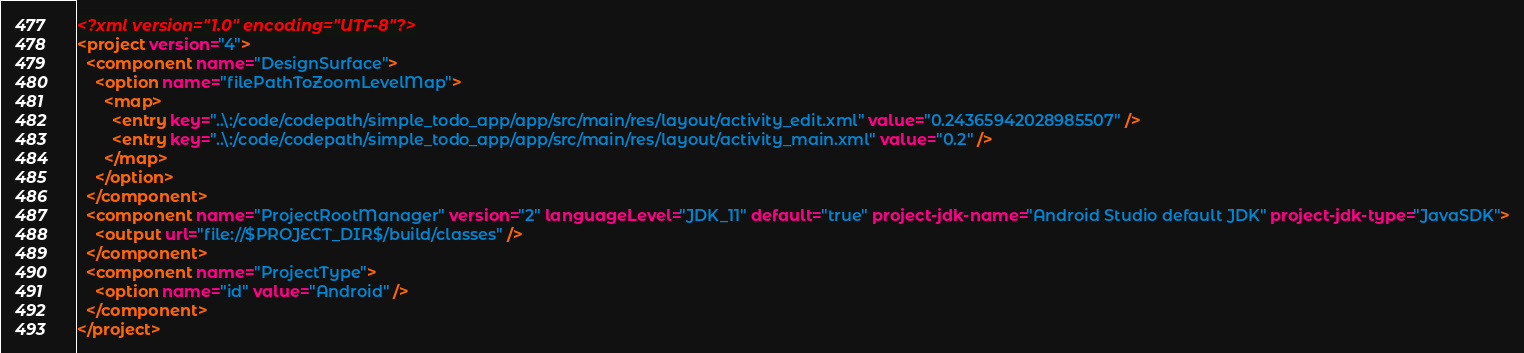Convert code to text. <code><loc_0><loc_0><loc_500><loc_500><_XML_><?xml version="1.0" encoding="UTF-8"?>
<project version="4">
  <component name="DesignSurface">
    <option name="filePathToZoomLevelMap">
      <map>
        <entry key="..\:/code/codepath/simple_todo_app/app/src/main/res/layout/activity_edit.xml" value="0.24365942028985507" />
        <entry key="..\:/code/codepath/simple_todo_app/app/src/main/res/layout/activity_main.xml" value="0.2" />
      </map>
    </option>
  </component>
  <component name="ProjectRootManager" version="2" languageLevel="JDK_11" default="true" project-jdk-name="Android Studio default JDK" project-jdk-type="JavaSDK">
    <output url="file://$PROJECT_DIR$/build/classes" />
  </component>
  <component name="ProjectType">
    <option name="id" value="Android" />
  </component>
</project></code> 